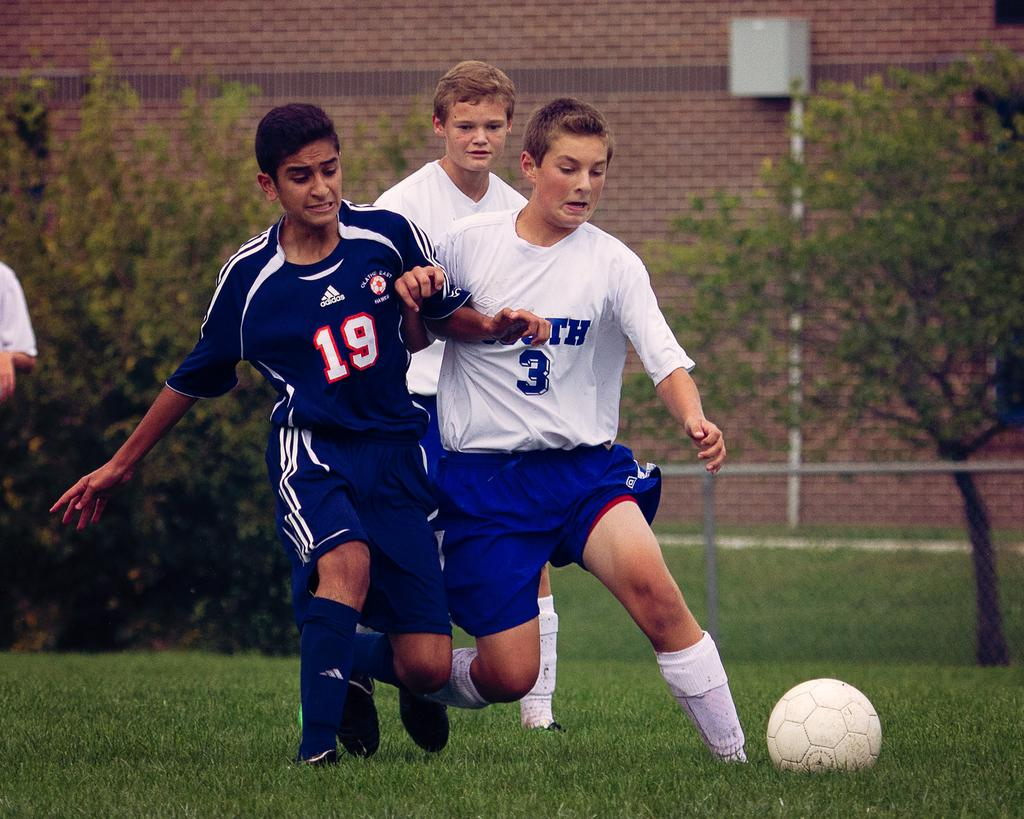<image>
Present a compact description of the photo's key features. The boy wearing the blue jersey has the number "19" on it. 